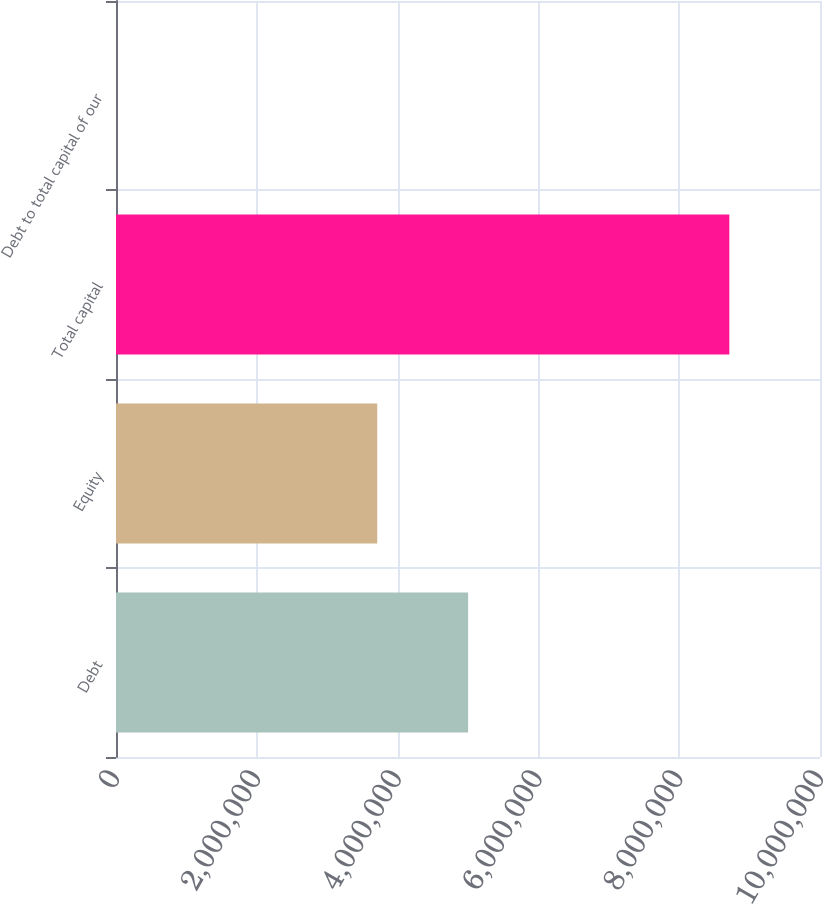Convert chart. <chart><loc_0><loc_0><loc_500><loc_500><bar_chart><fcel>Debt<fcel>Equity<fcel>Total capital<fcel>Debt to total capital of our<nl><fcel>5.00162e+06<fcel>3.71077e+06<fcel>8.7124e+06<fcel>57.4<nl></chart> 